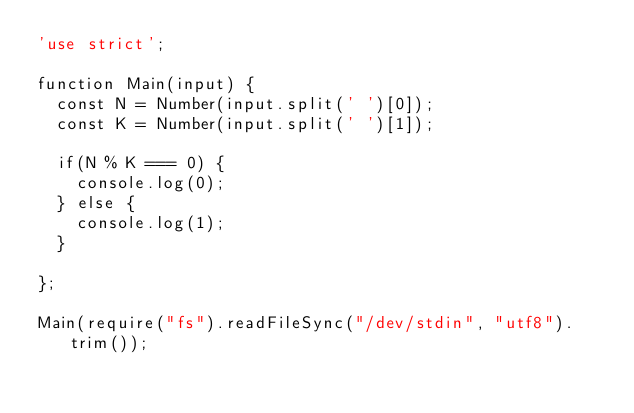<code> <loc_0><loc_0><loc_500><loc_500><_JavaScript_>'use strict';

function Main(input) {
  const N = Number(input.split(' ')[0]);
  const K = Number(input.split(' ')[1]);

  if(N % K === 0) {
    console.log(0);
  } else {
    console.log(1);
  }

};

Main(require("fs").readFileSync("/dev/stdin", "utf8").trim());
</code> 